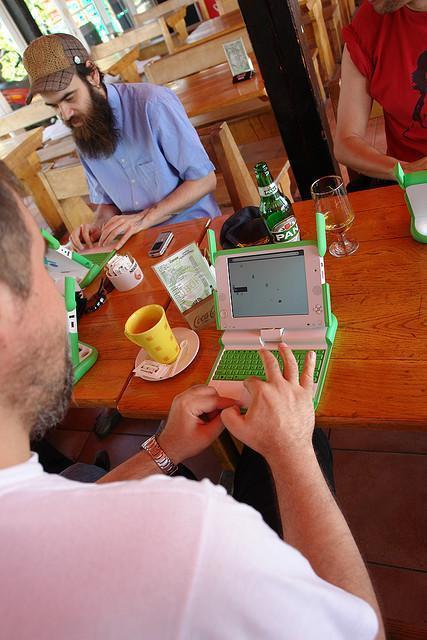How many dining tables are there?
Give a very brief answer. 3. How many people are in the photo?
Give a very brief answer. 3. 